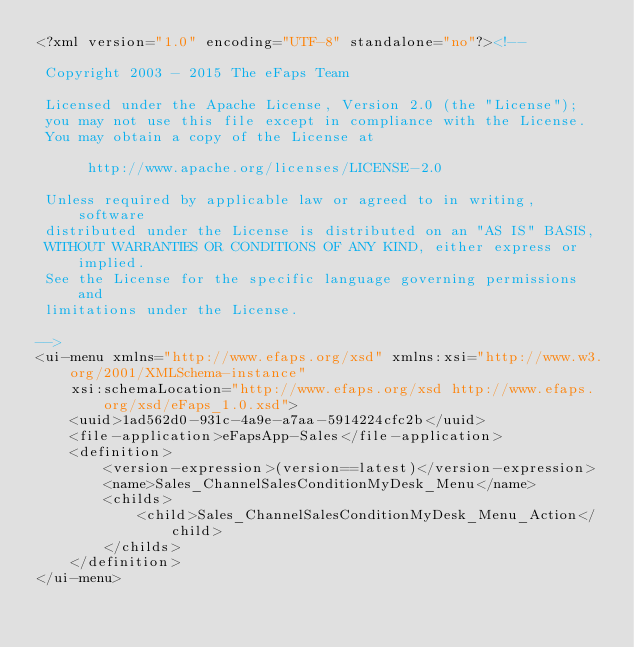Convert code to text. <code><loc_0><loc_0><loc_500><loc_500><_XML_><?xml version="1.0" encoding="UTF-8" standalone="no"?><!--

 Copyright 2003 - 2015 The eFaps Team

 Licensed under the Apache License, Version 2.0 (the "License");
 you may not use this file except in compliance with the License.
 You may obtain a copy of the License at

      http://www.apache.org/licenses/LICENSE-2.0

 Unless required by applicable law or agreed to in writing, software
 distributed under the License is distributed on an "AS IS" BASIS,
 WITHOUT WARRANTIES OR CONDITIONS OF ANY KIND, either express or implied.
 See the License for the specific language governing permissions and
 limitations under the License.

-->
<ui-menu xmlns="http://www.efaps.org/xsd" xmlns:xsi="http://www.w3.org/2001/XMLSchema-instance"
    xsi:schemaLocation="http://www.efaps.org/xsd http://www.efaps.org/xsd/eFaps_1.0.xsd">
    <uuid>1ad562d0-931c-4a9e-a7aa-5914224cfc2b</uuid>
    <file-application>eFapsApp-Sales</file-application>
    <definition>
        <version-expression>(version==latest)</version-expression>
        <name>Sales_ChannelSalesConditionMyDesk_Menu</name>
        <childs>
            <child>Sales_ChannelSalesConditionMyDesk_Menu_Action</child>
        </childs>
    </definition>
</ui-menu>
</code> 